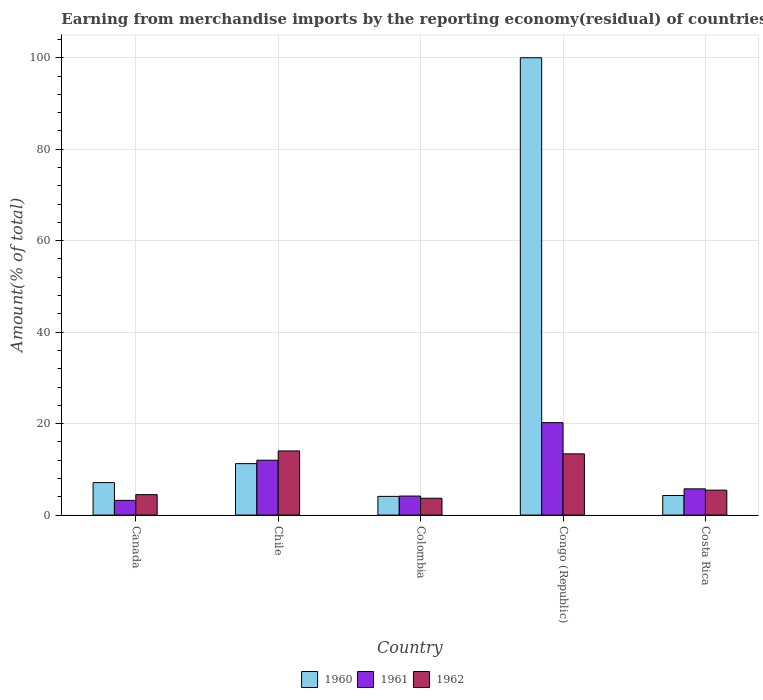How many different coloured bars are there?
Your response must be concise. 3. How many bars are there on the 5th tick from the left?
Offer a very short reply. 3. How many bars are there on the 5th tick from the right?
Your answer should be very brief. 3. What is the label of the 2nd group of bars from the left?
Ensure brevity in your answer.  Chile. In how many cases, is the number of bars for a given country not equal to the number of legend labels?
Provide a short and direct response. 0. What is the percentage of amount earned from merchandise imports in 1962 in Chile?
Provide a succinct answer. 14.02. Across all countries, what is the maximum percentage of amount earned from merchandise imports in 1960?
Your answer should be very brief. 100. Across all countries, what is the minimum percentage of amount earned from merchandise imports in 1960?
Offer a terse response. 4.09. In which country was the percentage of amount earned from merchandise imports in 1962 maximum?
Keep it short and to the point. Chile. What is the total percentage of amount earned from merchandise imports in 1961 in the graph?
Your answer should be very brief. 45.31. What is the difference between the percentage of amount earned from merchandise imports in 1961 in Canada and that in Colombia?
Keep it short and to the point. -0.94. What is the difference between the percentage of amount earned from merchandise imports in 1960 in Chile and the percentage of amount earned from merchandise imports in 1962 in Congo (Republic)?
Give a very brief answer. -2.14. What is the average percentage of amount earned from merchandise imports in 1960 per country?
Give a very brief answer. 25.34. What is the difference between the percentage of amount earned from merchandise imports of/in 1960 and percentage of amount earned from merchandise imports of/in 1962 in Canada?
Provide a succinct answer. 2.63. What is the ratio of the percentage of amount earned from merchandise imports in 1962 in Canada to that in Chile?
Offer a very short reply. 0.32. Is the percentage of amount earned from merchandise imports in 1961 in Canada less than that in Costa Rica?
Offer a terse response. Yes. What is the difference between the highest and the second highest percentage of amount earned from merchandise imports in 1961?
Offer a terse response. -8.21. What is the difference between the highest and the lowest percentage of amount earned from merchandise imports in 1961?
Offer a terse response. 16.99. Is the sum of the percentage of amount earned from merchandise imports in 1961 in Chile and Colombia greater than the maximum percentage of amount earned from merchandise imports in 1962 across all countries?
Provide a short and direct response. Yes. What does the 3rd bar from the right in Chile represents?
Provide a succinct answer. 1960. Are all the bars in the graph horizontal?
Offer a terse response. No. How many countries are there in the graph?
Offer a terse response. 5. What is the difference between two consecutive major ticks on the Y-axis?
Offer a very short reply. 20. Are the values on the major ticks of Y-axis written in scientific E-notation?
Your response must be concise. No. Does the graph contain any zero values?
Provide a succinct answer. No. Where does the legend appear in the graph?
Offer a very short reply. Bottom center. How many legend labels are there?
Your answer should be very brief. 3. What is the title of the graph?
Provide a short and direct response. Earning from merchandise imports by the reporting economy(residual) of countries. Does "1978" appear as one of the legend labels in the graph?
Your answer should be compact. No. What is the label or title of the X-axis?
Provide a short and direct response. Country. What is the label or title of the Y-axis?
Keep it short and to the point. Amount(% of total). What is the Amount(% of total) of 1960 in Canada?
Make the answer very short. 7.1. What is the Amount(% of total) of 1961 in Canada?
Ensure brevity in your answer.  3.22. What is the Amount(% of total) in 1962 in Canada?
Offer a terse response. 4.47. What is the Amount(% of total) in 1960 in Chile?
Provide a short and direct response. 11.25. What is the Amount(% of total) of 1961 in Chile?
Provide a short and direct response. 12. What is the Amount(% of total) in 1962 in Chile?
Provide a succinct answer. 14.02. What is the Amount(% of total) of 1960 in Colombia?
Give a very brief answer. 4.09. What is the Amount(% of total) of 1961 in Colombia?
Give a very brief answer. 4.16. What is the Amount(% of total) of 1962 in Colombia?
Ensure brevity in your answer.  3.68. What is the Amount(% of total) in 1961 in Congo (Republic)?
Provide a short and direct response. 20.21. What is the Amount(% of total) of 1962 in Congo (Republic)?
Make the answer very short. 13.38. What is the Amount(% of total) of 1960 in Costa Rica?
Your answer should be compact. 4.28. What is the Amount(% of total) of 1961 in Costa Rica?
Keep it short and to the point. 5.73. What is the Amount(% of total) of 1962 in Costa Rica?
Your answer should be very brief. 5.45. Across all countries, what is the maximum Amount(% of total) of 1961?
Offer a terse response. 20.21. Across all countries, what is the maximum Amount(% of total) in 1962?
Make the answer very short. 14.02. Across all countries, what is the minimum Amount(% of total) of 1960?
Your answer should be very brief. 4.09. Across all countries, what is the minimum Amount(% of total) in 1961?
Provide a short and direct response. 3.22. Across all countries, what is the minimum Amount(% of total) of 1962?
Provide a succinct answer. 3.68. What is the total Amount(% of total) in 1960 in the graph?
Provide a succinct answer. 126.71. What is the total Amount(% of total) of 1961 in the graph?
Keep it short and to the point. 45.31. What is the total Amount(% of total) in 1962 in the graph?
Your answer should be compact. 41. What is the difference between the Amount(% of total) of 1960 in Canada and that in Chile?
Provide a succinct answer. -4.15. What is the difference between the Amount(% of total) of 1961 in Canada and that in Chile?
Keep it short and to the point. -8.78. What is the difference between the Amount(% of total) of 1962 in Canada and that in Chile?
Give a very brief answer. -9.56. What is the difference between the Amount(% of total) in 1960 in Canada and that in Colombia?
Offer a terse response. 3.01. What is the difference between the Amount(% of total) of 1961 in Canada and that in Colombia?
Provide a short and direct response. -0.94. What is the difference between the Amount(% of total) of 1962 in Canada and that in Colombia?
Your answer should be compact. 0.79. What is the difference between the Amount(% of total) of 1960 in Canada and that in Congo (Republic)?
Offer a very short reply. -92.9. What is the difference between the Amount(% of total) in 1961 in Canada and that in Congo (Republic)?
Provide a succinct answer. -16.99. What is the difference between the Amount(% of total) of 1962 in Canada and that in Congo (Republic)?
Your answer should be compact. -8.92. What is the difference between the Amount(% of total) of 1960 in Canada and that in Costa Rica?
Make the answer very short. 2.82. What is the difference between the Amount(% of total) in 1961 in Canada and that in Costa Rica?
Make the answer very short. -2.52. What is the difference between the Amount(% of total) of 1962 in Canada and that in Costa Rica?
Make the answer very short. -0.99. What is the difference between the Amount(% of total) of 1960 in Chile and that in Colombia?
Give a very brief answer. 7.16. What is the difference between the Amount(% of total) of 1961 in Chile and that in Colombia?
Offer a terse response. 7.84. What is the difference between the Amount(% of total) of 1962 in Chile and that in Colombia?
Give a very brief answer. 10.35. What is the difference between the Amount(% of total) in 1960 in Chile and that in Congo (Republic)?
Ensure brevity in your answer.  -88.75. What is the difference between the Amount(% of total) in 1961 in Chile and that in Congo (Republic)?
Provide a short and direct response. -8.21. What is the difference between the Amount(% of total) in 1962 in Chile and that in Congo (Republic)?
Your answer should be very brief. 0.64. What is the difference between the Amount(% of total) of 1960 in Chile and that in Costa Rica?
Provide a succinct answer. 6.97. What is the difference between the Amount(% of total) of 1961 in Chile and that in Costa Rica?
Make the answer very short. 6.26. What is the difference between the Amount(% of total) of 1962 in Chile and that in Costa Rica?
Give a very brief answer. 8.57. What is the difference between the Amount(% of total) in 1960 in Colombia and that in Congo (Republic)?
Offer a terse response. -95.91. What is the difference between the Amount(% of total) in 1961 in Colombia and that in Congo (Republic)?
Offer a terse response. -16.05. What is the difference between the Amount(% of total) in 1962 in Colombia and that in Congo (Republic)?
Provide a succinct answer. -9.71. What is the difference between the Amount(% of total) in 1960 in Colombia and that in Costa Rica?
Give a very brief answer. -0.19. What is the difference between the Amount(% of total) in 1961 in Colombia and that in Costa Rica?
Keep it short and to the point. -1.57. What is the difference between the Amount(% of total) in 1962 in Colombia and that in Costa Rica?
Give a very brief answer. -1.78. What is the difference between the Amount(% of total) of 1960 in Congo (Republic) and that in Costa Rica?
Ensure brevity in your answer.  95.72. What is the difference between the Amount(% of total) in 1961 in Congo (Republic) and that in Costa Rica?
Provide a short and direct response. 14.47. What is the difference between the Amount(% of total) in 1962 in Congo (Republic) and that in Costa Rica?
Your answer should be very brief. 7.93. What is the difference between the Amount(% of total) in 1960 in Canada and the Amount(% of total) in 1961 in Chile?
Provide a short and direct response. -4.9. What is the difference between the Amount(% of total) in 1960 in Canada and the Amount(% of total) in 1962 in Chile?
Your answer should be compact. -6.92. What is the difference between the Amount(% of total) of 1961 in Canada and the Amount(% of total) of 1962 in Chile?
Make the answer very short. -10.81. What is the difference between the Amount(% of total) of 1960 in Canada and the Amount(% of total) of 1961 in Colombia?
Offer a very short reply. 2.94. What is the difference between the Amount(% of total) in 1960 in Canada and the Amount(% of total) in 1962 in Colombia?
Ensure brevity in your answer.  3.42. What is the difference between the Amount(% of total) in 1961 in Canada and the Amount(% of total) in 1962 in Colombia?
Make the answer very short. -0.46. What is the difference between the Amount(% of total) in 1960 in Canada and the Amount(% of total) in 1961 in Congo (Republic)?
Provide a succinct answer. -13.11. What is the difference between the Amount(% of total) in 1960 in Canada and the Amount(% of total) in 1962 in Congo (Republic)?
Offer a terse response. -6.28. What is the difference between the Amount(% of total) of 1961 in Canada and the Amount(% of total) of 1962 in Congo (Republic)?
Your response must be concise. -10.17. What is the difference between the Amount(% of total) in 1960 in Canada and the Amount(% of total) in 1961 in Costa Rica?
Offer a very short reply. 1.37. What is the difference between the Amount(% of total) in 1960 in Canada and the Amount(% of total) in 1962 in Costa Rica?
Ensure brevity in your answer.  1.65. What is the difference between the Amount(% of total) of 1961 in Canada and the Amount(% of total) of 1962 in Costa Rica?
Make the answer very short. -2.23. What is the difference between the Amount(% of total) of 1960 in Chile and the Amount(% of total) of 1961 in Colombia?
Your answer should be very brief. 7.09. What is the difference between the Amount(% of total) of 1960 in Chile and the Amount(% of total) of 1962 in Colombia?
Give a very brief answer. 7.57. What is the difference between the Amount(% of total) of 1961 in Chile and the Amount(% of total) of 1962 in Colombia?
Your answer should be compact. 8.32. What is the difference between the Amount(% of total) in 1960 in Chile and the Amount(% of total) in 1961 in Congo (Republic)?
Provide a short and direct response. -8.96. What is the difference between the Amount(% of total) in 1960 in Chile and the Amount(% of total) in 1962 in Congo (Republic)?
Keep it short and to the point. -2.14. What is the difference between the Amount(% of total) of 1961 in Chile and the Amount(% of total) of 1962 in Congo (Republic)?
Your response must be concise. -1.39. What is the difference between the Amount(% of total) in 1960 in Chile and the Amount(% of total) in 1961 in Costa Rica?
Make the answer very short. 5.51. What is the difference between the Amount(% of total) of 1960 in Chile and the Amount(% of total) of 1962 in Costa Rica?
Keep it short and to the point. 5.8. What is the difference between the Amount(% of total) of 1961 in Chile and the Amount(% of total) of 1962 in Costa Rica?
Make the answer very short. 6.54. What is the difference between the Amount(% of total) in 1960 in Colombia and the Amount(% of total) in 1961 in Congo (Republic)?
Offer a terse response. -16.12. What is the difference between the Amount(% of total) in 1960 in Colombia and the Amount(% of total) in 1962 in Congo (Republic)?
Offer a very short reply. -9.29. What is the difference between the Amount(% of total) in 1961 in Colombia and the Amount(% of total) in 1962 in Congo (Republic)?
Make the answer very short. -9.22. What is the difference between the Amount(% of total) of 1960 in Colombia and the Amount(% of total) of 1961 in Costa Rica?
Your response must be concise. -1.64. What is the difference between the Amount(% of total) of 1960 in Colombia and the Amount(% of total) of 1962 in Costa Rica?
Provide a succinct answer. -1.36. What is the difference between the Amount(% of total) of 1961 in Colombia and the Amount(% of total) of 1962 in Costa Rica?
Ensure brevity in your answer.  -1.29. What is the difference between the Amount(% of total) of 1960 in Congo (Republic) and the Amount(% of total) of 1961 in Costa Rica?
Your answer should be compact. 94.27. What is the difference between the Amount(% of total) of 1960 in Congo (Republic) and the Amount(% of total) of 1962 in Costa Rica?
Provide a succinct answer. 94.55. What is the difference between the Amount(% of total) in 1961 in Congo (Republic) and the Amount(% of total) in 1962 in Costa Rica?
Make the answer very short. 14.76. What is the average Amount(% of total) in 1960 per country?
Your answer should be compact. 25.34. What is the average Amount(% of total) of 1961 per country?
Give a very brief answer. 9.06. What is the average Amount(% of total) of 1962 per country?
Your answer should be compact. 8.2. What is the difference between the Amount(% of total) of 1960 and Amount(% of total) of 1961 in Canada?
Your response must be concise. 3.88. What is the difference between the Amount(% of total) in 1960 and Amount(% of total) in 1962 in Canada?
Give a very brief answer. 2.63. What is the difference between the Amount(% of total) in 1961 and Amount(% of total) in 1962 in Canada?
Your response must be concise. -1.25. What is the difference between the Amount(% of total) in 1960 and Amount(% of total) in 1961 in Chile?
Give a very brief answer. -0.75. What is the difference between the Amount(% of total) of 1960 and Amount(% of total) of 1962 in Chile?
Keep it short and to the point. -2.78. What is the difference between the Amount(% of total) in 1961 and Amount(% of total) in 1962 in Chile?
Your answer should be very brief. -2.03. What is the difference between the Amount(% of total) in 1960 and Amount(% of total) in 1961 in Colombia?
Ensure brevity in your answer.  -0.07. What is the difference between the Amount(% of total) of 1960 and Amount(% of total) of 1962 in Colombia?
Give a very brief answer. 0.41. What is the difference between the Amount(% of total) in 1961 and Amount(% of total) in 1962 in Colombia?
Provide a succinct answer. 0.48. What is the difference between the Amount(% of total) of 1960 and Amount(% of total) of 1961 in Congo (Republic)?
Keep it short and to the point. 79.79. What is the difference between the Amount(% of total) of 1960 and Amount(% of total) of 1962 in Congo (Republic)?
Offer a terse response. 86.62. What is the difference between the Amount(% of total) in 1961 and Amount(% of total) in 1962 in Congo (Republic)?
Provide a short and direct response. 6.83. What is the difference between the Amount(% of total) of 1960 and Amount(% of total) of 1961 in Costa Rica?
Make the answer very short. -1.46. What is the difference between the Amount(% of total) of 1960 and Amount(% of total) of 1962 in Costa Rica?
Your answer should be compact. -1.17. What is the difference between the Amount(% of total) in 1961 and Amount(% of total) in 1962 in Costa Rica?
Make the answer very short. 0.28. What is the ratio of the Amount(% of total) of 1960 in Canada to that in Chile?
Make the answer very short. 0.63. What is the ratio of the Amount(% of total) in 1961 in Canada to that in Chile?
Your answer should be very brief. 0.27. What is the ratio of the Amount(% of total) of 1962 in Canada to that in Chile?
Provide a short and direct response. 0.32. What is the ratio of the Amount(% of total) of 1960 in Canada to that in Colombia?
Make the answer very short. 1.74. What is the ratio of the Amount(% of total) in 1961 in Canada to that in Colombia?
Give a very brief answer. 0.77. What is the ratio of the Amount(% of total) in 1962 in Canada to that in Colombia?
Provide a succinct answer. 1.22. What is the ratio of the Amount(% of total) in 1960 in Canada to that in Congo (Republic)?
Give a very brief answer. 0.07. What is the ratio of the Amount(% of total) in 1961 in Canada to that in Congo (Republic)?
Your answer should be compact. 0.16. What is the ratio of the Amount(% of total) in 1962 in Canada to that in Congo (Republic)?
Provide a succinct answer. 0.33. What is the ratio of the Amount(% of total) of 1960 in Canada to that in Costa Rica?
Offer a terse response. 1.66. What is the ratio of the Amount(% of total) of 1961 in Canada to that in Costa Rica?
Keep it short and to the point. 0.56. What is the ratio of the Amount(% of total) of 1962 in Canada to that in Costa Rica?
Ensure brevity in your answer.  0.82. What is the ratio of the Amount(% of total) in 1960 in Chile to that in Colombia?
Your response must be concise. 2.75. What is the ratio of the Amount(% of total) of 1961 in Chile to that in Colombia?
Offer a very short reply. 2.88. What is the ratio of the Amount(% of total) in 1962 in Chile to that in Colombia?
Give a very brief answer. 3.82. What is the ratio of the Amount(% of total) of 1960 in Chile to that in Congo (Republic)?
Offer a terse response. 0.11. What is the ratio of the Amount(% of total) in 1961 in Chile to that in Congo (Republic)?
Make the answer very short. 0.59. What is the ratio of the Amount(% of total) in 1962 in Chile to that in Congo (Republic)?
Give a very brief answer. 1.05. What is the ratio of the Amount(% of total) in 1960 in Chile to that in Costa Rica?
Make the answer very short. 2.63. What is the ratio of the Amount(% of total) in 1961 in Chile to that in Costa Rica?
Keep it short and to the point. 2.09. What is the ratio of the Amount(% of total) of 1962 in Chile to that in Costa Rica?
Offer a very short reply. 2.57. What is the ratio of the Amount(% of total) of 1960 in Colombia to that in Congo (Republic)?
Provide a succinct answer. 0.04. What is the ratio of the Amount(% of total) in 1961 in Colombia to that in Congo (Republic)?
Give a very brief answer. 0.21. What is the ratio of the Amount(% of total) in 1962 in Colombia to that in Congo (Republic)?
Your response must be concise. 0.27. What is the ratio of the Amount(% of total) of 1960 in Colombia to that in Costa Rica?
Provide a short and direct response. 0.96. What is the ratio of the Amount(% of total) in 1961 in Colombia to that in Costa Rica?
Your response must be concise. 0.73. What is the ratio of the Amount(% of total) in 1962 in Colombia to that in Costa Rica?
Your answer should be very brief. 0.67. What is the ratio of the Amount(% of total) of 1960 in Congo (Republic) to that in Costa Rica?
Your response must be concise. 23.38. What is the ratio of the Amount(% of total) in 1961 in Congo (Republic) to that in Costa Rica?
Your answer should be compact. 3.52. What is the ratio of the Amount(% of total) of 1962 in Congo (Republic) to that in Costa Rica?
Provide a succinct answer. 2.45. What is the difference between the highest and the second highest Amount(% of total) in 1960?
Give a very brief answer. 88.75. What is the difference between the highest and the second highest Amount(% of total) of 1961?
Your answer should be very brief. 8.21. What is the difference between the highest and the second highest Amount(% of total) in 1962?
Your answer should be compact. 0.64. What is the difference between the highest and the lowest Amount(% of total) in 1960?
Offer a terse response. 95.91. What is the difference between the highest and the lowest Amount(% of total) in 1961?
Make the answer very short. 16.99. What is the difference between the highest and the lowest Amount(% of total) of 1962?
Your answer should be very brief. 10.35. 